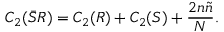Convert formula to latex. <formula><loc_0><loc_0><loc_500><loc_500>C _ { 2 } ( \bar { S } R ) = C _ { 2 } ( R ) + C _ { 2 } ( S ) + \frac { 2 n \tilde { n } } { N } .</formula> 